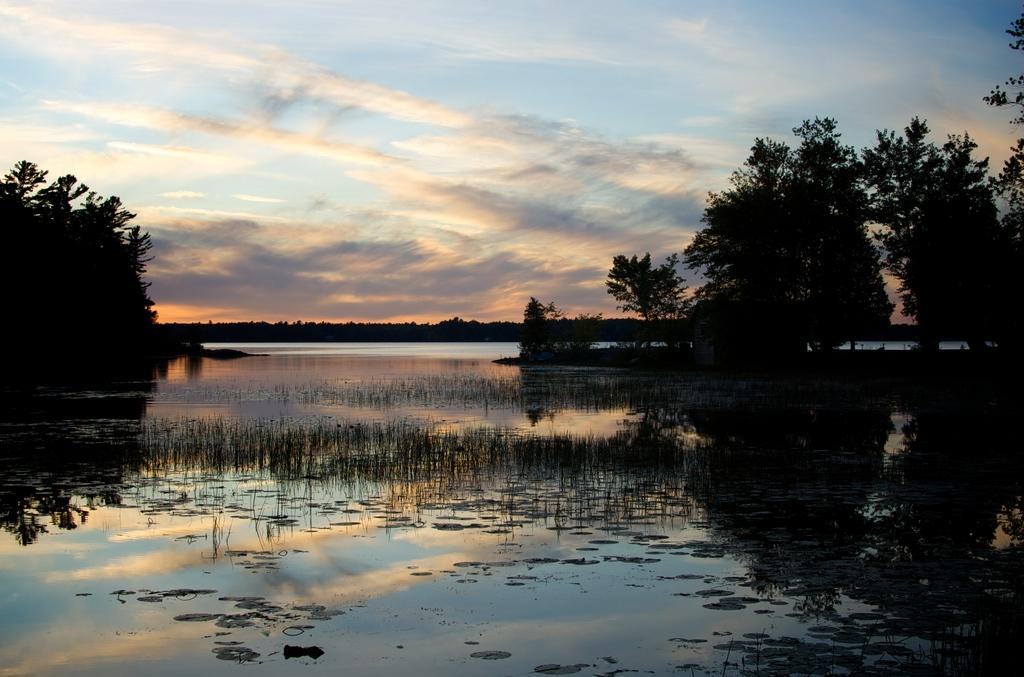What is located in the middle of the image? There is water in the middle of the image. What type of vegetation is on either side of the image? There are trees on either side of the image. What is visible at the top of the image? The sky is visible at the top of the image. What type of humor can be seen in the image? There is no humor present in the image; it features water, trees, and the sky. What type of plant is depicted in the image? The image does not depict a specific plant; it features trees in general. 